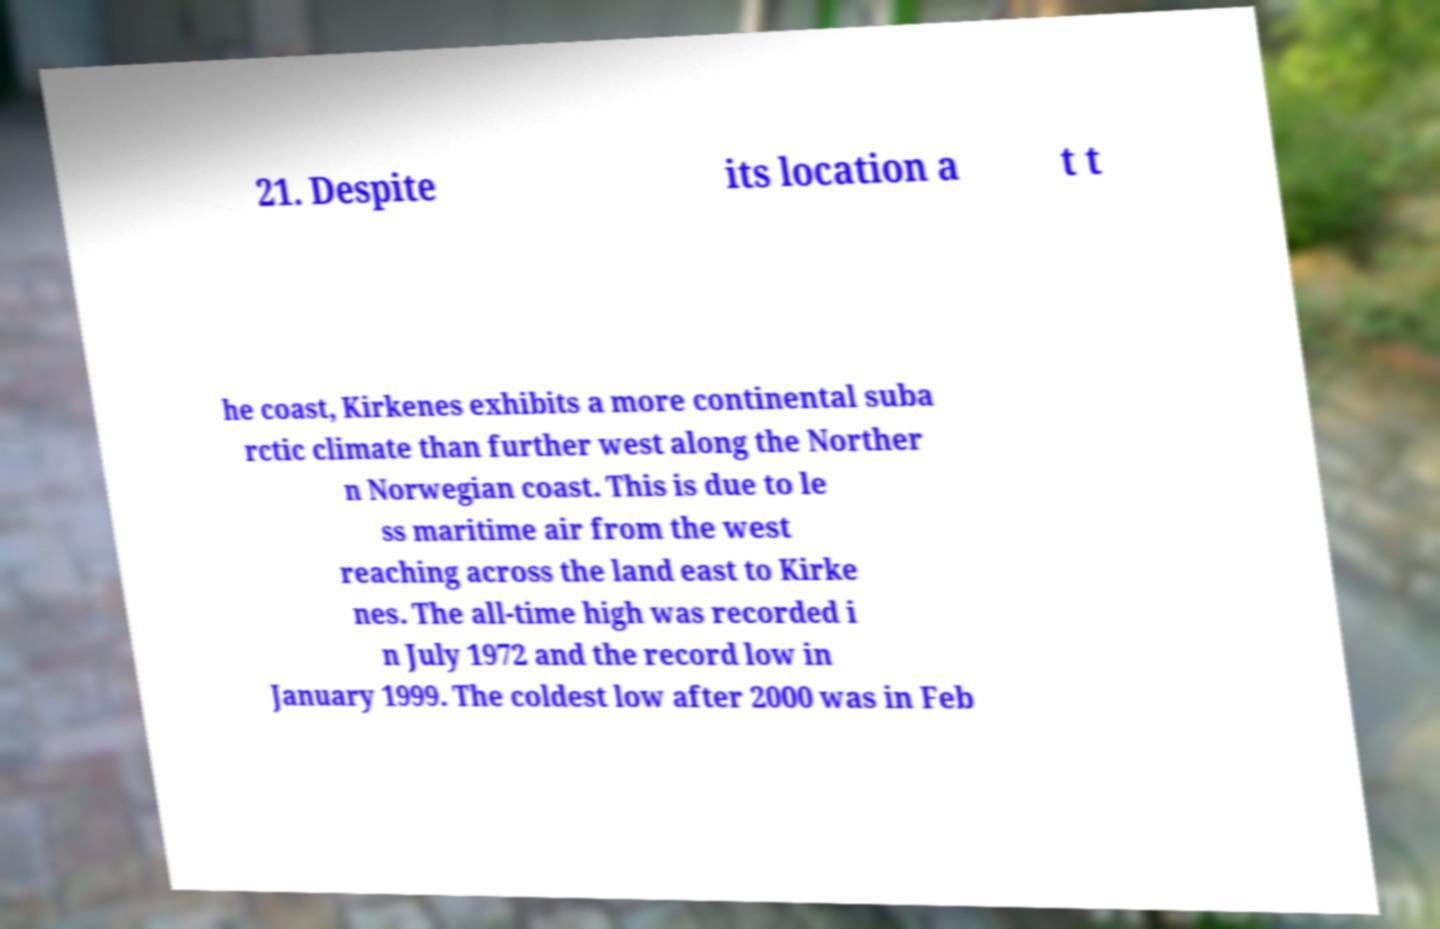Please read and relay the text visible in this image. What does it say? 21. Despite its location a t t he coast, Kirkenes exhibits a more continental suba rctic climate than further west along the Norther n Norwegian coast. This is due to le ss maritime air from the west reaching across the land east to Kirke nes. The all-time high was recorded i n July 1972 and the record low in January 1999. The coldest low after 2000 was in Feb 